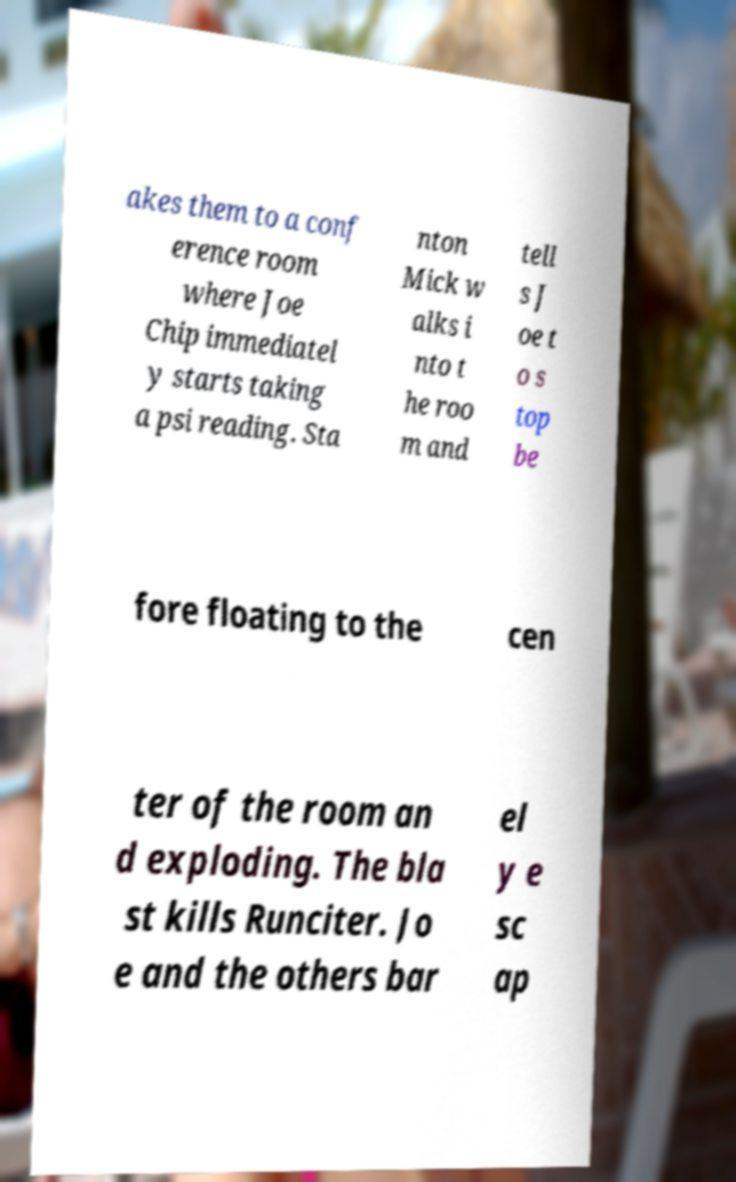Could you assist in decoding the text presented in this image and type it out clearly? akes them to a conf erence room where Joe Chip immediatel y starts taking a psi reading. Sta nton Mick w alks i nto t he roo m and tell s J oe t o s top be fore floating to the cen ter of the room an d exploding. The bla st kills Runciter. Jo e and the others bar el y e sc ap 